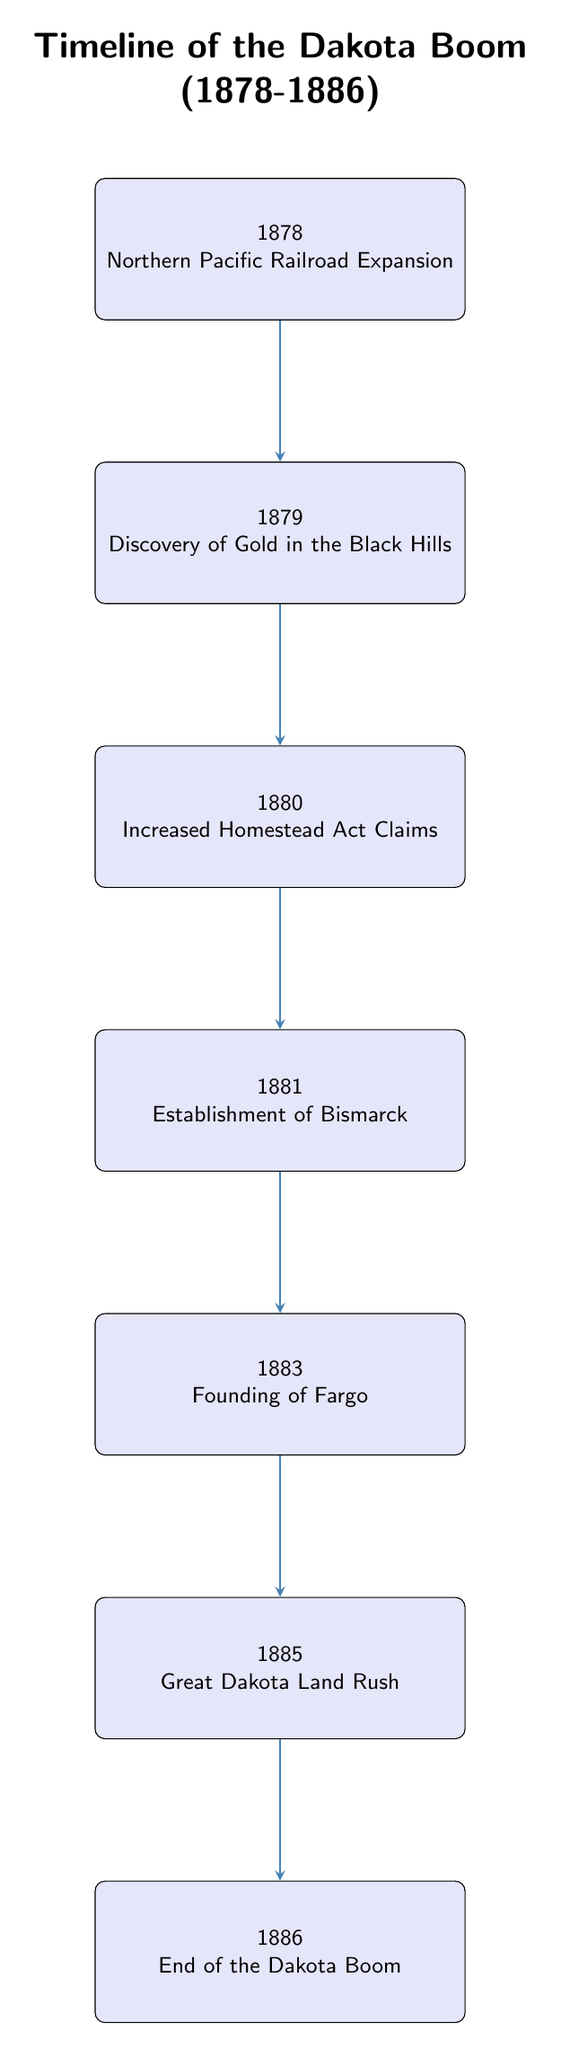What year did the discovery of gold in the Black Hills occur? The diagram lists the event "Discovery of Gold in the Black Hills" under the year 1879. Therefore, the answer is directly taken from the node corresponding to that event.
Answer: 1879 How many key events are shown in the timeline? By counting the nodes in the flow chart, there are a total of 7 events listed: from 1878 to 1886. This includes one event for each year.
Answer: 7 What event follows the establishment of Bismarck in the timeline? The timeline indicates that after the event "Establishment of Bismarck" in 1881, the next event is "Founding of Fargo" in 1883. The relationship between these events can be directly inferred from their arrangement.
Answer: Founding of Fargo Which event marks the beginning of the Great Dakota Land Rush? The flow chart shows "Great Dakota Land Rush" occurring in the year 1885. This is indicated by the placement of the node corresponding to this event.
Answer: Great Dakota Land Rush What event happened immediately before the end of the Dakota Boom? The diagram shows that the event "End of the Dakota Boom" occurs after "Great Dakota Land Rush" in 1885, thus establishing that the latter is immediately before the former.
Answer: Great Dakota Land Rush What was a significant factor that led to the population growth in 1879? The diagram specifies that the "Discovery of Gold in the Black Hills" in 1879 was a key event that attracted miners and settlers, leading to population growth. This is a direct mention in the event description node.
Answer: Discovery of Gold in the Black Hills Which year is associated with the implementation of the Enlarged Homestead Act? The timeline positions this event in the year 1880, making it easy to reference directly from the node for that year.
Answer: 1880 